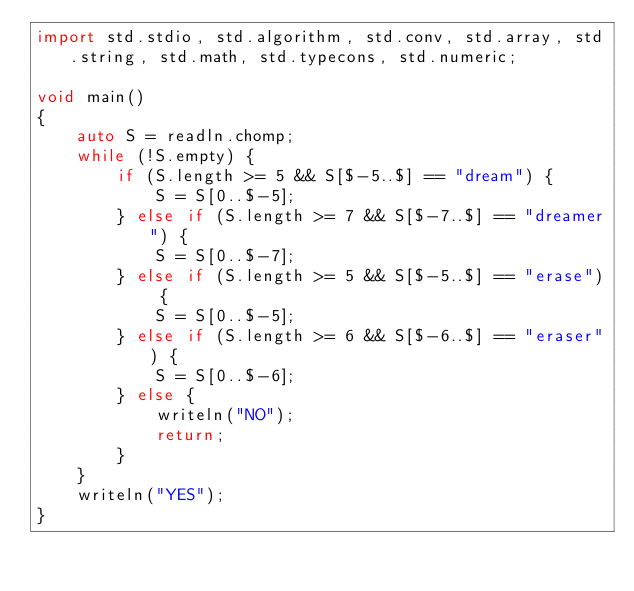<code> <loc_0><loc_0><loc_500><loc_500><_D_>import std.stdio, std.algorithm, std.conv, std.array, std.string, std.math, std.typecons, std.numeric;

void main()
{
    auto S = readln.chomp;
    while (!S.empty) {
        if (S.length >= 5 && S[$-5..$] == "dream") {
            S = S[0..$-5];
        } else if (S.length >= 7 && S[$-7..$] == "dreamer") {
            S = S[0..$-7];
        } else if (S.length >= 5 && S[$-5..$] == "erase") {
            S = S[0..$-5];
        } else if (S.length >= 6 && S[$-6..$] == "eraser") {
            S = S[0..$-6];
        } else {
            writeln("NO");
            return;
        }
    }
    writeln("YES");
}</code> 